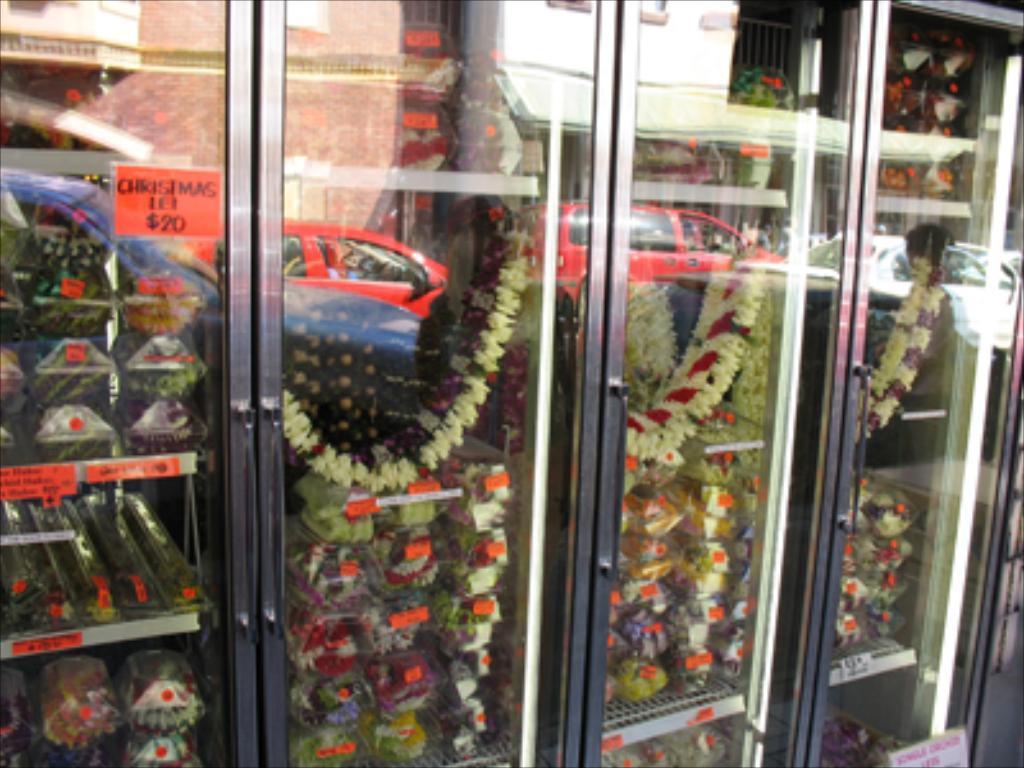In one or two sentences, can you explain what this image depicts? In this image we can see cupboards, inside the cupboards there are garlands and few objects, and we can see the reflection of car and buildings on the cupboards. 